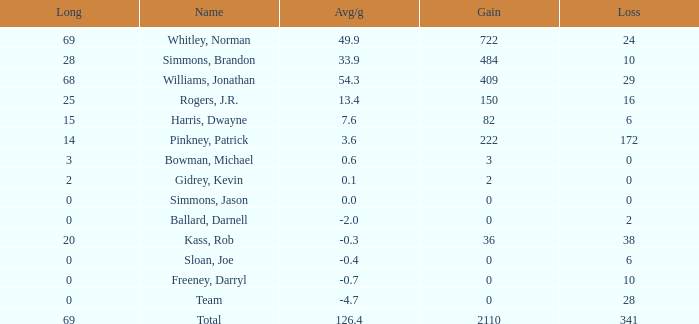What is the highest Loss, when Long is greater than 0, when Gain is greater than 484, and when Avg/g is greater than 126.4? None. 